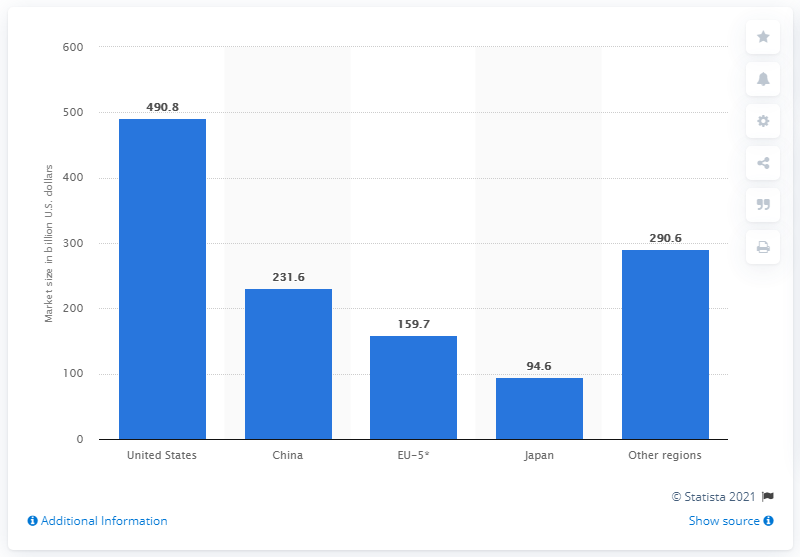List a handful of essential elements in this visual. In 2018, the market size of pharmaceuticals in the United States was approximately 490.8 billion dollars. According to data from 2018, China was the largest pharmaceutical market in the world. 